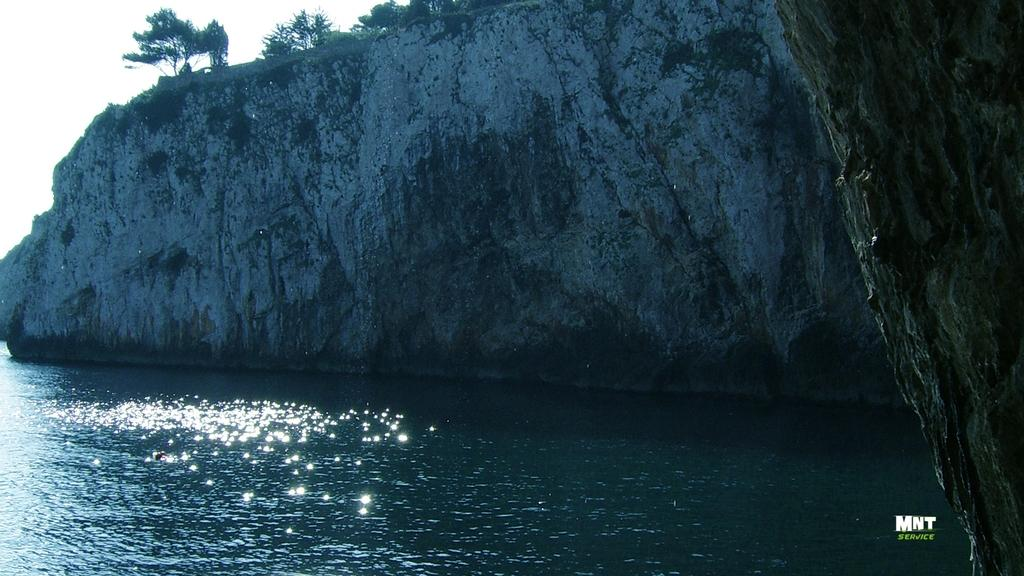What is located on the left side of the image? There is water on the left side of the image. What can be found on the bottom right of the image? There is a watermark on the bottom right of the image. What type of landform is on the right side of the image? There is a hill on the right side of the image. What is visible in the background of the image? There is a mountain and the sky in the background of the image. What type of can is being used for dinner in the image? There is no can or dinner present in the image. Can you describe the bird that is flying in the image? There is no bird present in the image. 